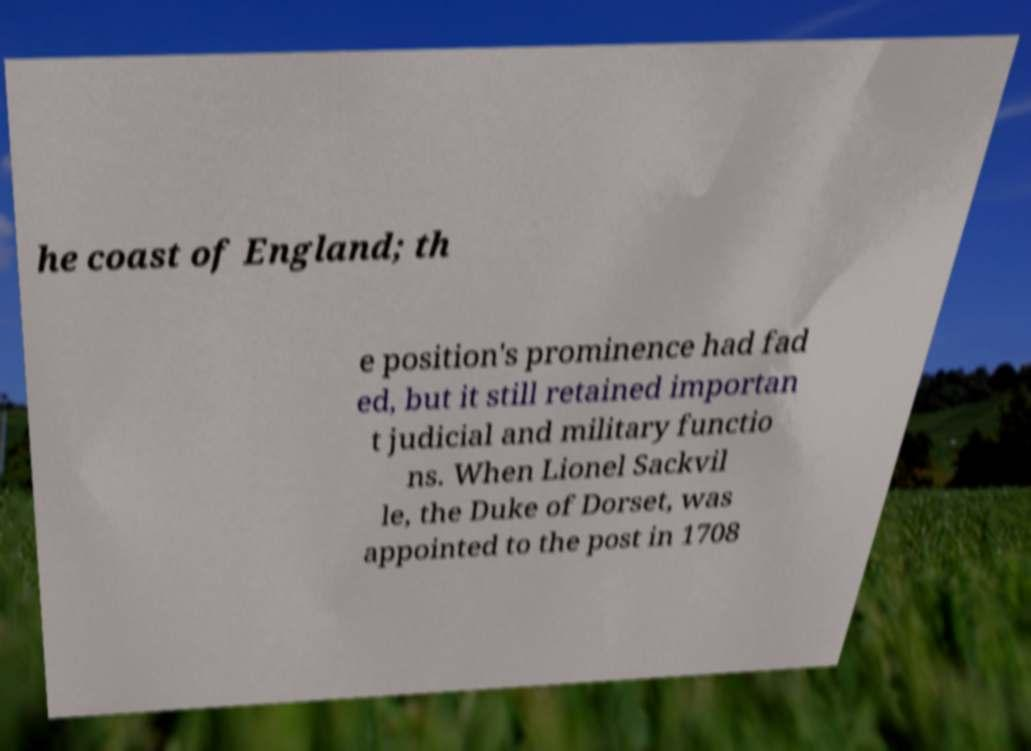Please read and relay the text visible in this image. What does it say? he coast of England; th e position's prominence had fad ed, but it still retained importan t judicial and military functio ns. When Lionel Sackvil le, the Duke of Dorset, was appointed to the post in 1708 